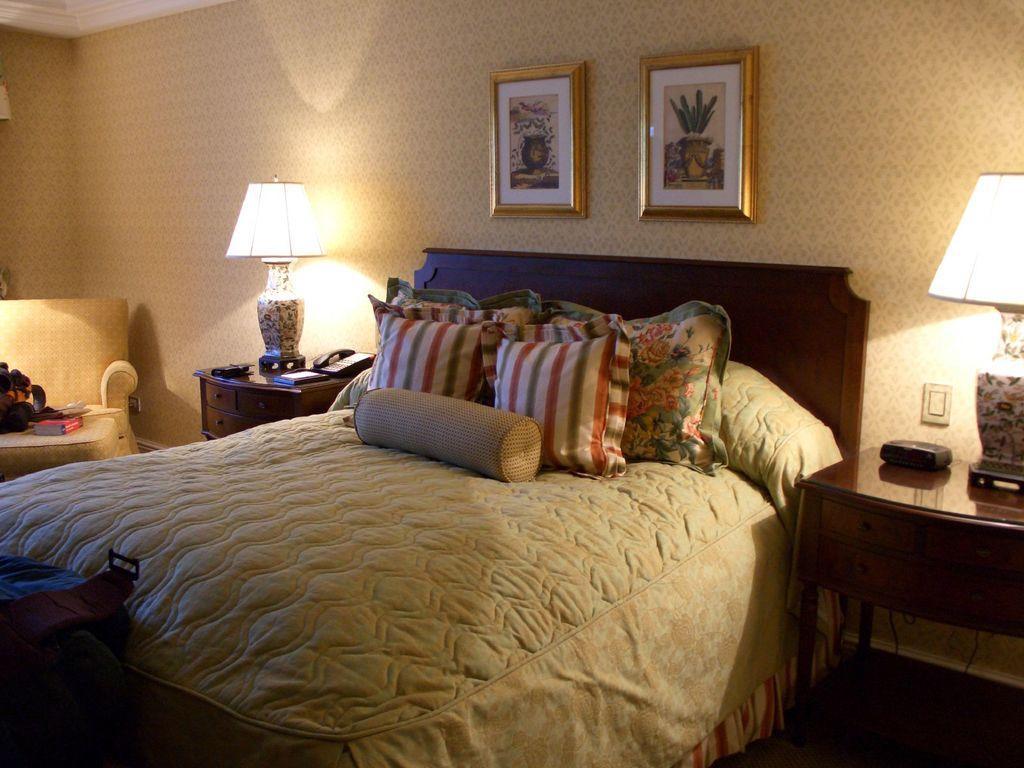Can you describe this image briefly? In this image I can see a bed with five cushions placed on the bed. These are the two photo frames attached to the wall. This is a couch,on this I can see a book and some other object placed on it. This is a table with a lamp,telephone and some object placed on it. At the right corner of the image I can see another table with a lamp and some object placed on it which is black in color. 